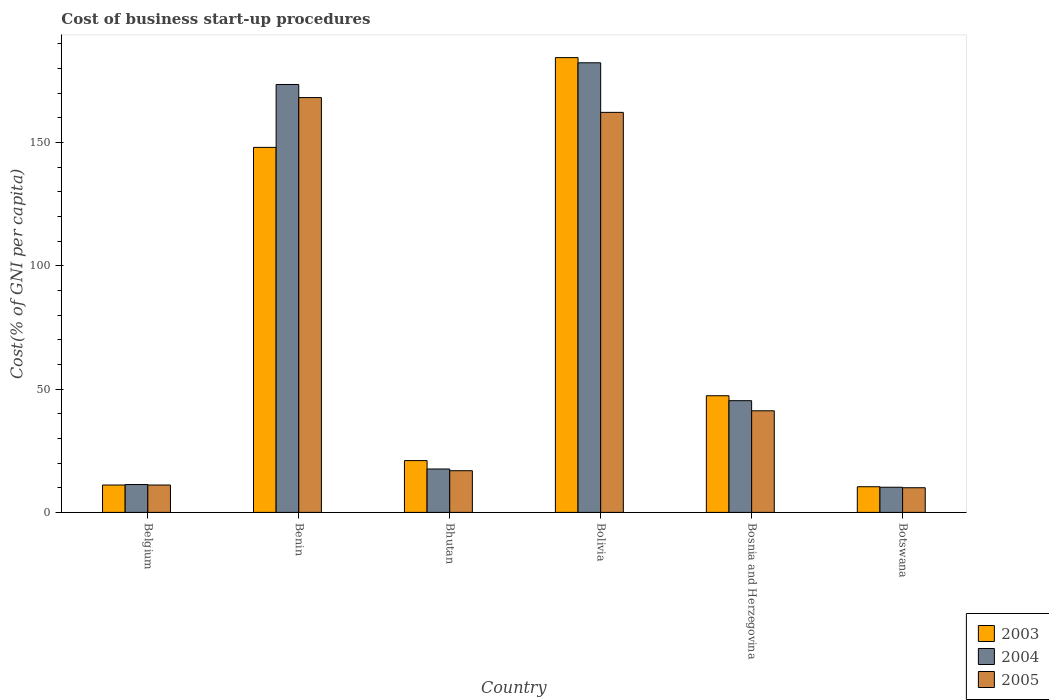How many groups of bars are there?
Provide a short and direct response. 6. Are the number of bars on each tick of the X-axis equal?
Your response must be concise. Yes. How many bars are there on the 2nd tick from the left?
Ensure brevity in your answer.  3. How many bars are there on the 3rd tick from the right?
Ensure brevity in your answer.  3. What is the label of the 6th group of bars from the left?
Make the answer very short. Botswana. In how many cases, is the number of bars for a given country not equal to the number of legend labels?
Offer a terse response. 0. What is the cost of business start-up procedures in 2004 in Bosnia and Herzegovina?
Offer a very short reply. 45.3. Across all countries, what is the maximum cost of business start-up procedures in 2003?
Offer a terse response. 184.4. Across all countries, what is the minimum cost of business start-up procedures in 2004?
Ensure brevity in your answer.  10.2. In which country was the cost of business start-up procedures in 2005 maximum?
Provide a short and direct response. Benin. In which country was the cost of business start-up procedures in 2003 minimum?
Ensure brevity in your answer.  Botswana. What is the total cost of business start-up procedures in 2004 in the graph?
Keep it short and to the point. 440.2. What is the difference between the cost of business start-up procedures in 2003 in Belgium and that in Benin?
Offer a terse response. -136.9. What is the difference between the cost of business start-up procedures in 2003 in Botswana and the cost of business start-up procedures in 2004 in Bolivia?
Keep it short and to the point. -171.9. What is the average cost of business start-up procedures in 2004 per country?
Ensure brevity in your answer.  73.37. What is the difference between the cost of business start-up procedures of/in 2004 and cost of business start-up procedures of/in 2003 in Bosnia and Herzegovina?
Your answer should be compact. -2. In how many countries, is the cost of business start-up procedures in 2005 greater than 70 %?
Your response must be concise. 2. What is the ratio of the cost of business start-up procedures in 2005 in Bhutan to that in Botswana?
Ensure brevity in your answer.  1.69. Is the difference between the cost of business start-up procedures in 2004 in Benin and Botswana greater than the difference between the cost of business start-up procedures in 2003 in Benin and Botswana?
Your answer should be very brief. Yes. What is the difference between the highest and the second highest cost of business start-up procedures in 2003?
Ensure brevity in your answer.  36.4. What is the difference between the highest and the lowest cost of business start-up procedures in 2003?
Offer a very short reply. 174. In how many countries, is the cost of business start-up procedures in 2005 greater than the average cost of business start-up procedures in 2005 taken over all countries?
Your answer should be compact. 2. Is the sum of the cost of business start-up procedures in 2005 in Belgium and Benin greater than the maximum cost of business start-up procedures in 2004 across all countries?
Your response must be concise. No. What does the 2nd bar from the left in Bolivia represents?
Provide a short and direct response. 2004. Is it the case that in every country, the sum of the cost of business start-up procedures in 2003 and cost of business start-up procedures in 2004 is greater than the cost of business start-up procedures in 2005?
Your response must be concise. Yes. Are all the bars in the graph horizontal?
Provide a short and direct response. No. What is the difference between two consecutive major ticks on the Y-axis?
Offer a terse response. 50. Does the graph contain any zero values?
Give a very brief answer. No. Where does the legend appear in the graph?
Offer a terse response. Bottom right. How many legend labels are there?
Keep it short and to the point. 3. How are the legend labels stacked?
Keep it short and to the point. Vertical. What is the title of the graph?
Your answer should be very brief. Cost of business start-up procedures. What is the label or title of the Y-axis?
Your answer should be compact. Cost(% of GNI per capita). What is the Cost(% of GNI per capita) of 2003 in Belgium?
Provide a short and direct response. 11.1. What is the Cost(% of GNI per capita) in 2004 in Belgium?
Offer a terse response. 11.3. What is the Cost(% of GNI per capita) of 2005 in Belgium?
Offer a very short reply. 11.1. What is the Cost(% of GNI per capita) of 2003 in Benin?
Offer a very short reply. 148. What is the Cost(% of GNI per capita) in 2004 in Benin?
Give a very brief answer. 173.5. What is the Cost(% of GNI per capita) in 2005 in Benin?
Your answer should be compact. 168.2. What is the Cost(% of GNI per capita) in 2003 in Bhutan?
Offer a very short reply. 21. What is the Cost(% of GNI per capita) in 2004 in Bhutan?
Offer a very short reply. 17.6. What is the Cost(% of GNI per capita) of 2003 in Bolivia?
Offer a terse response. 184.4. What is the Cost(% of GNI per capita) in 2004 in Bolivia?
Provide a short and direct response. 182.3. What is the Cost(% of GNI per capita) of 2005 in Bolivia?
Your response must be concise. 162.2. What is the Cost(% of GNI per capita) in 2003 in Bosnia and Herzegovina?
Provide a short and direct response. 47.3. What is the Cost(% of GNI per capita) in 2004 in Bosnia and Herzegovina?
Give a very brief answer. 45.3. What is the Cost(% of GNI per capita) in 2005 in Bosnia and Herzegovina?
Make the answer very short. 41.2. What is the Cost(% of GNI per capita) in 2004 in Botswana?
Your response must be concise. 10.2. Across all countries, what is the maximum Cost(% of GNI per capita) of 2003?
Your answer should be compact. 184.4. Across all countries, what is the maximum Cost(% of GNI per capita) of 2004?
Offer a very short reply. 182.3. Across all countries, what is the maximum Cost(% of GNI per capita) of 2005?
Your answer should be compact. 168.2. What is the total Cost(% of GNI per capita) in 2003 in the graph?
Make the answer very short. 422.2. What is the total Cost(% of GNI per capita) of 2004 in the graph?
Offer a terse response. 440.2. What is the total Cost(% of GNI per capita) in 2005 in the graph?
Give a very brief answer. 409.6. What is the difference between the Cost(% of GNI per capita) of 2003 in Belgium and that in Benin?
Your answer should be compact. -136.9. What is the difference between the Cost(% of GNI per capita) in 2004 in Belgium and that in Benin?
Provide a short and direct response. -162.2. What is the difference between the Cost(% of GNI per capita) of 2005 in Belgium and that in Benin?
Offer a terse response. -157.1. What is the difference between the Cost(% of GNI per capita) of 2005 in Belgium and that in Bhutan?
Your answer should be compact. -5.8. What is the difference between the Cost(% of GNI per capita) in 2003 in Belgium and that in Bolivia?
Offer a very short reply. -173.3. What is the difference between the Cost(% of GNI per capita) of 2004 in Belgium and that in Bolivia?
Offer a terse response. -171. What is the difference between the Cost(% of GNI per capita) in 2005 in Belgium and that in Bolivia?
Make the answer very short. -151.1. What is the difference between the Cost(% of GNI per capita) of 2003 in Belgium and that in Bosnia and Herzegovina?
Your answer should be very brief. -36.2. What is the difference between the Cost(% of GNI per capita) of 2004 in Belgium and that in Bosnia and Herzegovina?
Offer a very short reply. -34. What is the difference between the Cost(% of GNI per capita) in 2005 in Belgium and that in Bosnia and Herzegovina?
Your answer should be very brief. -30.1. What is the difference between the Cost(% of GNI per capita) of 2003 in Benin and that in Bhutan?
Your response must be concise. 127. What is the difference between the Cost(% of GNI per capita) of 2004 in Benin and that in Bhutan?
Ensure brevity in your answer.  155.9. What is the difference between the Cost(% of GNI per capita) in 2005 in Benin and that in Bhutan?
Provide a succinct answer. 151.3. What is the difference between the Cost(% of GNI per capita) in 2003 in Benin and that in Bolivia?
Offer a very short reply. -36.4. What is the difference between the Cost(% of GNI per capita) of 2004 in Benin and that in Bolivia?
Offer a very short reply. -8.8. What is the difference between the Cost(% of GNI per capita) of 2005 in Benin and that in Bolivia?
Make the answer very short. 6. What is the difference between the Cost(% of GNI per capita) of 2003 in Benin and that in Bosnia and Herzegovina?
Provide a short and direct response. 100.7. What is the difference between the Cost(% of GNI per capita) of 2004 in Benin and that in Bosnia and Herzegovina?
Give a very brief answer. 128.2. What is the difference between the Cost(% of GNI per capita) of 2005 in Benin and that in Bosnia and Herzegovina?
Provide a short and direct response. 127. What is the difference between the Cost(% of GNI per capita) of 2003 in Benin and that in Botswana?
Make the answer very short. 137.6. What is the difference between the Cost(% of GNI per capita) of 2004 in Benin and that in Botswana?
Make the answer very short. 163.3. What is the difference between the Cost(% of GNI per capita) of 2005 in Benin and that in Botswana?
Offer a terse response. 158.2. What is the difference between the Cost(% of GNI per capita) of 2003 in Bhutan and that in Bolivia?
Keep it short and to the point. -163.4. What is the difference between the Cost(% of GNI per capita) in 2004 in Bhutan and that in Bolivia?
Your answer should be compact. -164.7. What is the difference between the Cost(% of GNI per capita) of 2005 in Bhutan and that in Bolivia?
Keep it short and to the point. -145.3. What is the difference between the Cost(% of GNI per capita) in 2003 in Bhutan and that in Bosnia and Herzegovina?
Offer a very short reply. -26.3. What is the difference between the Cost(% of GNI per capita) of 2004 in Bhutan and that in Bosnia and Herzegovina?
Your answer should be very brief. -27.7. What is the difference between the Cost(% of GNI per capita) in 2005 in Bhutan and that in Bosnia and Herzegovina?
Make the answer very short. -24.3. What is the difference between the Cost(% of GNI per capita) in 2004 in Bhutan and that in Botswana?
Your response must be concise. 7.4. What is the difference between the Cost(% of GNI per capita) in 2003 in Bolivia and that in Bosnia and Herzegovina?
Provide a short and direct response. 137.1. What is the difference between the Cost(% of GNI per capita) in 2004 in Bolivia and that in Bosnia and Herzegovina?
Your answer should be very brief. 137. What is the difference between the Cost(% of GNI per capita) in 2005 in Bolivia and that in Bosnia and Herzegovina?
Offer a very short reply. 121. What is the difference between the Cost(% of GNI per capita) in 2003 in Bolivia and that in Botswana?
Give a very brief answer. 174. What is the difference between the Cost(% of GNI per capita) of 2004 in Bolivia and that in Botswana?
Make the answer very short. 172.1. What is the difference between the Cost(% of GNI per capita) in 2005 in Bolivia and that in Botswana?
Your answer should be compact. 152.2. What is the difference between the Cost(% of GNI per capita) in 2003 in Bosnia and Herzegovina and that in Botswana?
Your answer should be compact. 36.9. What is the difference between the Cost(% of GNI per capita) of 2004 in Bosnia and Herzegovina and that in Botswana?
Give a very brief answer. 35.1. What is the difference between the Cost(% of GNI per capita) of 2005 in Bosnia and Herzegovina and that in Botswana?
Your answer should be very brief. 31.2. What is the difference between the Cost(% of GNI per capita) in 2003 in Belgium and the Cost(% of GNI per capita) in 2004 in Benin?
Ensure brevity in your answer.  -162.4. What is the difference between the Cost(% of GNI per capita) of 2003 in Belgium and the Cost(% of GNI per capita) of 2005 in Benin?
Offer a terse response. -157.1. What is the difference between the Cost(% of GNI per capita) in 2004 in Belgium and the Cost(% of GNI per capita) in 2005 in Benin?
Offer a very short reply. -156.9. What is the difference between the Cost(% of GNI per capita) of 2003 in Belgium and the Cost(% of GNI per capita) of 2004 in Bhutan?
Offer a very short reply. -6.5. What is the difference between the Cost(% of GNI per capita) of 2003 in Belgium and the Cost(% of GNI per capita) of 2005 in Bhutan?
Your answer should be compact. -5.8. What is the difference between the Cost(% of GNI per capita) in 2004 in Belgium and the Cost(% of GNI per capita) in 2005 in Bhutan?
Provide a short and direct response. -5.6. What is the difference between the Cost(% of GNI per capita) of 2003 in Belgium and the Cost(% of GNI per capita) of 2004 in Bolivia?
Provide a succinct answer. -171.2. What is the difference between the Cost(% of GNI per capita) in 2003 in Belgium and the Cost(% of GNI per capita) in 2005 in Bolivia?
Provide a succinct answer. -151.1. What is the difference between the Cost(% of GNI per capita) in 2004 in Belgium and the Cost(% of GNI per capita) in 2005 in Bolivia?
Ensure brevity in your answer.  -150.9. What is the difference between the Cost(% of GNI per capita) of 2003 in Belgium and the Cost(% of GNI per capita) of 2004 in Bosnia and Herzegovina?
Make the answer very short. -34.2. What is the difference between the Cost(% of GNI per capita) of 2003 in Belgium and the Cost(% of GNI per capita) of 2005 in Bosnia and Herzegovina?
Offer a terse response. -30.1. What is the difference between the Cost(% of GNI per capita) in 2004 in Belgium and the Cost(% of GNI per capita) in 2005 in Bosnia and Herzegovina?
Provide a short and direct response. -29.9. What is the difference between the Cost(% of GNI per capita) of 2003 in Belgium and the Cost(% of GNI per capita) of 2004 in Botswana?
Ensure brevity in your answer.  0.9. What is the difference between the Cost(% of GNI per capita) of 2004 in Belgium and the Cost(% of GNI per capita) of 2005 in Botswana?
Provide a succinct answer. 1.3. What is the difference between the Cost(% of GNI per capita) in 2003 in Benin and the Cost(% of GNI per capita) in 2004 in Bhutan?
Provide a short and direct response. 130.4. What is the difference between the Cost(% of GNI per capita) in 2003 in Benin and the Cost(% of GNI per capita) in 2005 in Bhutan?
Your response must be concise. 131.1. What is the difference between the Cost(% of GNI per capita) in 2004 in Benin and the Cost(% of GNI per capita) in 2005 in Bhutan?
Ensure brevity in your answer.  156.6. What is the difference between the Cost(% of GNI per capita) of 2003 in Benin and the Cost(% of GNI per capita) of 2004 in Bolivia?
Your answer should be very brief. -34.3. What is the difference between the Cost(% of GNI per capita) of 2004 in Benin and the Cost(% of GNI per capita) of 2005 in Bolivia?
Provide a succinct answer. 11.3. What is the difference between the Cost(% of GNI per capita) in 2003 in Benin and the Cost(% of GNI per capita) in 2004 in Bosnia and Herzegovina?
Provide a short and direct response. 102.7. What is the difference between the Cost(% of GNI per capita) in 2003 in Benin and the Cost(% of GNI per capita) in 2005 in Bosnia and Herzegovina?
Your answer should be compact. 106.8. What is the difference between the Cost(% of GNI per capita) in 2004 in Benin and the Cost(% of GNI per capita) in 2005 in Bosnia and Herzegovina?
Offer a terse response. 132.3. What is the difference between the Cost(% of GNI per capita) of 2003 in Benin and the Cost(% of GNI per capita) of 2004 in Botswana?
Provide a succinct answer. 137.8. What is the difference between the Cost(% of GNI per capita) of 2003 in Benin and the Cost(% of GNI per capita) of 2005 in Botswana?
Make the answer very short. 138. What is the difference between the Cost(% of GNI per capita) of 2004 in Benin and the Cost(% of GNI per capita) of 2005 in Botswana?
Your answer should be compact. 163.5. What is the difference between the Cost(% of GNI per capita) in 2003 in Bhutan and the Cost(% of GNI per capita) in 2004 in Bolivia?
Your answer should be compact. -161.3. What is the difference between the Cost(% of GNI per capita) in 2003 in Bhutan and the Cost(% of GNI per capita) in 2005 in Bolivia?
Give a very brief answer. -141.2. What is the difference between the Cost(% of GNI per capita) in 2004 in Bhutan and the Cost(% of GNI per capita) in 2005 in Bolivia?
Your answer should be compact. -144.6. What is the difference between the Cost(% of GNI per capita) of 2003 in Bhutan and the Cost(% of GNI per capita) of 2004 in Bosnia and Herzegovina?
Your answer should be compact. -24.3. What is the difference between the Cost(% of GNI per capita) of 2003 in Bhutan and the Cost(% of GNI per capita) of 2005 in Bosnia and Herzegovina?
Your answer should be very brief. -20.2. What is the difference between the Cost(% of GNI per capita) of 2004 in Bhutan and the Cost(% of GNI per capita) of 2005 in Bosnia and Herzegovina?
Keep it short and to the point. -23.6. What is the difference between the Cost(% of GNI per capita) in 2004 in Bhutan and the Cost(% of GNI per capita) in 2005 in Botswana?
Provide a succinct answer. 7.6. What is the difference between the Cost(% of GNI per capita) in 2003 in Bolivia and the Cost(% of GNI per capita) in 2004 in Bosnia and Herzegovina?
Your answer should be very brief. 139.1. What is the difference between the Cost(% of GNI per capita) in 2003 in Bolivia and the Cost(% of GNI per capita) in 2005 in Bosnia and Herzegovina?
Your answer should be very brief. 143.2. What is the difference between the Cost(% of GNI per capita) of 2004 in Bolivia and the Cost(% of GNI per capita) of 2005 in Bosnia and Herzegovina?
Offer a terse response. 141.1. What is the difference between the Cost(% of GNI per capita) in 2003 in Bolivia and the Cost(% of GNI per capita) in 2004 in Botswana?
Your answer should be compact. 174.2. What is the difference between the Cost(% of GNI per capita) of 2003 in Bolivia and the Cost(% of GNI per capita) of 2005 in Botswana?
Make the answer very short. 174.4. What is the difference between the Cost(% of GNI per capita) of 2004 in Bolivia and the Cost(% of GNI per capita) of 2005 in Botswana?
Your answer should be compact. 172.3. What is the difference between the Cost(% of GNI per capita) of 2003 in Bosnia and Herzegovina and the Cost(% of GNI per capita) of 2004 in Botswana?
Make the answer very short. 37.1. What is the difference between the Cost(% of GNI per capita) in 2003 in Bosnia and Herzegovina and the Cost(% of GNI per capita) in 2005 in Botswana?
Provide a succinct answer. 37.3. What is the difference between the Cost(% of GNI per capita) of 2004 in Bosnia and Herzegovina and the Cost(% of GNI per capita) of 2005 in Botswana?
Offer a very short reply. 35.3. What is the average Cost(% of GNI per capita) of 2003 per country?
Provide a succinct answer. 70.37. What is the average Cost(% of GNI per capita) of 2004 per country?
Make the answer very short. 73.37. What is the average Cost(% of GNI per capita) in 2005 per country?
Provide a succinct answer. 68.27. What is the difference between the Cost(% of GNI per capita) in 2003 and Cost(% of GNI per capita) in 2004 in Belgium?
Ensure brevity in your answer.  -0.2. What is the difference between the Cost(% of GNI per capita) in 2003 and Cost(% of GNI per capita) in 2004 in Benin?
Your answer should be compact. -25.5. What is the difference between the Cost(% of GNI per capita) in 2003 and Cost(% of GNI per capita) in 2005 in Benin?
Offer a very short reply. -20.2. What is the difference between the Cost(% of GNI per capita) in 2004 and Cost(% of GNI per capita) in 2005 in Benin?
Provide a succinct answer. 5.3. What is the difference between the Cost(% of GNI per capita) of 2003 and Cost(% of GNI per capita) of 2004 in Bhutan?
Give a very brief answer. 3.4. What is the difference between the Cost(% of GNI per capita) of 2003 and Cost(% of GNI per capita) of 2005 in Bhutan?
Provide a succinct answer. 4.1. What is the difference between the Cost(% of GNI per capita) in 2004 and Cost(% of GNI per capita) in 2005 in Bhutan?
Your answer should be compact. 0.7. What is the difference between the Cost(% of GNI per capita) of 2003 and Cost(% of GNI per capita) of 2004 in Bolivia?
Your answer should be very brief. 2.1. What is the difference between the Cost(% of GNI per capita) in 2003 and Cost(% of GNI per capita) in 2005 in Bolivia?
Ensure brevity in your answer.  22.2. What is the difference between the Cost(% of GNI per capita) in 2004 and Cost(% of GNI per capita) in 2005 in Bolivia?
Your answer should be very brief. 20.1. What is the difference between the Cost(% of GNI per capita) in 2003 and Cost(% of GNI per capita) in 2004 in Bosnia and Herzegovina?
Offer a very short reply. 2. What is the difference between the Cost(% of GNI per capita) in 2003 and Cost(% of GNI per capita) in 2005 in Bosnia and Herzegovina?
Offer a terse response. 6.1. What is the difference between the Cost(% of GNI per capita) of 2004 and Cost(% of GNI per capita) of 2005 in Bosnia and Herzegovina?
Keep it short and to the point. 4.1. What is the difference between the Cost(% of GNI per capita) in 2003 and Cost(% of GNI per capita) in 2004 in Botswana?
Your answer should be compact. 0.2. What is the ratio of the Cost(% of GNI per capita) of 2003 in Belgium to that in Benin?
Your answer should be very brief. 0.07. What is the ratio of the Cost(% of GNI per capita) of 2004 in Belgium to that in Benin?
Your response must be concise. 0.07. What is the ratio of the Cost(% of GNI per capita) of 2005 in Belgium to that in Benin?
Make the answer very short. 0.07. What is the ratio of the Cost(% of GNI per capita) in 2003 in Belgium to that in Bhutan?
Your answer should be very brief. 0.53. What is the ratio of the Cost(% of GNI per capita) of 2004 in Belgium to that in Bhutan?
Provide a succinct answer. 0.64. What is the ratio of the Cost(% of GNI per capita) in 2005 in Belgium to that in Bhutan?
Make the answer very short. 0.66. What is the ratio of the Cost(% of GNI per capita) of 2003 in Belgium to that in Bolivia?
Offer a terse response. 0.06. What is the ratio of the Cost(% of GNI per capita) in 2004 in Belgium to that in Bolivia?
Offer a very short reply. 0.06. What is the ratio of the Cost(% of GNI per capita) of 2005 in Belgium to that in Bolivia?
Your answer should be very brief. 0.07. What is the ratio of the Cost(% of GNI per capita) in 2003 in Belgium to that in Bosnia and Herzegovina?
Your response must be concise. 0.23. What is the ratio of the Cost(% of GNI per capita) of 2004 in Belgium to that in Bosnia and Herzegovina?
Provide a succinct answer. 0.25. What is the ratio of the Cost(% of GNI per capita) of 2005 in Belgium to that in Bosnia and Herzegovina?
Your response must be concise. 0.27. What is the ratio of the Cost(% of GNI per capita) in 2003 in Belgium to that in Botswana?
Your response must be concise. 1.07. What is the ratio of the Cost(% of GNI per capita) of 2004 in Belgium to that in Botswana?
Ensure brevity in your answer.  1.11. What is the ratio of the Cost(% of GNI per capita) of 2005 in Belgium to that in Botswana?
Offer a very short reply. 1.11. What is the ratio of the Cost(% of GNI per capita) in 2003 in Benin to that in Bhutan?
Provide a succinct answer. 7.05. What is the ratio of the Cost(% of GNI per capita) of 2004 in Benin to that in Bhutan?
Offer a very short reply. 9.86. What is the ratio of the Cost(% of GNI per capita) in 2005 in Benin to that in Bhutan?
Provide a succinct answer. 9.95. What is the ratio of the Cost(% of GNI per capita) of 2003 in Benin to that in Bolivia?
Give a very brief answer. 0.8. What is the ratio of the Cost(% of GNI per capita) in 2004 in Benin to that in Bolivia?
Give a very brief answer. 0.95. What is the ratio of the Cost(% of GNI per capita) of 2003 in Benin to that in Bosnia and Herzegovina?
Keep it short and to the point. 3.13. What is the ratio of the Cost(% of GNI per capita) in 2004 in Benin to that in Bosnia and Herzegovina?
Offer a very short reply. 3.83. What is the ratio of the Cost(% of GNI per capita) of 2005 in Benin to that in Bosnia and Herzegovina?
Offer a terse response. 4.08. What is the ratio of the Cost(% of GNI per capita) in 2003 in Benin to that in Botswana?
Your answer should be very brief. 14.23. What is the ratio of the Cost(% of GNI per capita) of 2004 in Benin to that in Botswana?
Keep it short and to the point. 17.01. What is the ratio of the Cost(% of GNI per capita) in 2005 in Benin to that in Botswana?
Your answer should be very brief. 16.82. What is the ratio of the Cost(% of GNI per capita) in 2003 in Bhutan to that in Bolivia?
Provide a short and direct response. 0.11. What is the ratio of the Cost(% of GNI per capita) of 2004 in Bhutan to that in Bolivia?
Provide a succinct answer. 0.1. What is the ratio of the Cost(% of GNI per capita) in 2005 in Bhutan to that in Bolivia?
Your response must be concise. 0.1. What is the ratio of the Cost(% of GNI per capita) in 2003 in Bhutan to that in Bosnia and Herzegovina?
Give a very brief answer. 0.44. What is the ratio of the Cost(% of GNI per capita) of 2004 in Bhutan to that in Bosnia and Herzegovina?
Keep it short and to the point. 0.39. What is the ratio of the Cost(% of GNI per capita) in 2005 in Bhutan to that in Bosnia and Herzegovina?
Your answer should be compact. 0.41. What is the ratio of the Cost(% of GNI per capita) of 2003 in Bhutan to that in Botswana?
Provide a short and direct response. 2.02. What is the ratio of the Cost(% of GNI per capita) in 2004 in Bhutan to that in Botswana?
Provide a short and direct response. 1.73. What is the ratio of the Cost(% of GNI per capita) in 2005 in Bhutan to that in Botswana?
Your response must be concise. 1.69. What is the ratio of the Cost(% of GNI per capita) of 2003 in Bolivia to that in Bosnia and Herzegovina?
Make the answer very short. 3.9. What is the ratio of the Cost(% of GNI per capita) of 2004 in Bolivia to that in Bosnia and Herzegovina?
Your response must be concise. 4.02. What is the ratio of the Cost(% of GNI per capita) of 2005 in Bolivia to that in Bosnia and Herzegovina?
Give a very brief answer. 3.94. What is the ratio of the Cost(% of GNI per capita) in 2003 in Bolivia to that in Botswana?
Offer a very short reply. 17.73. What is the ratio of the Cost(% of GNI per capita) in 2004 in Bolivia to that in Botswana?
Give a very brief answer. 17.87. What is the ratio of the Cost(% of GNI per capita) of 2005 in Bolivia to that in Botswana?
Offer a terse response. 16.22. What is the ratio of the Cost(% of GNI per capita) in 2003 in Bosnia and Herzegovina to that in Botswana?
Give a very brief answer. 4.55. What is the ratio of the Cost(% of GNI per capita) in 2004 in Bosnia and Herzegovina to that in Botswana?
Give a very brief answer. 4.44. What is the ratio of the Cost(% of GNI per capita) in 2005 in Bosnia and Herzegovina to that in Botswana?
Make the answer very short. 4.12. What is the difference between the highest and the second highest Cost(% of GNI per capita) of 2003?
Offer a terse response. 36.4. What is the difference between the highest and the second highest Cost(% of GNI per capita) in 2004?
Keep it short and to the point. 8.8. What is the difference between the highest and the second highest Cost(% of GNI per capita) in 2005?
Your answer should be compact. 6. What is the difference between the highest and the lowest Cost(% of GNI per capita) in 2003?
Keep it short and to the point. 174. What is the difference between the highest and the lowest Cost(% of GNI per capita) in 2004?
Provide a succinct answer. 172.1. What is the difference between the highest and the lowest Cost(% of GNI per capita) of 2005?
Your answer should be very brief. 158.2. 